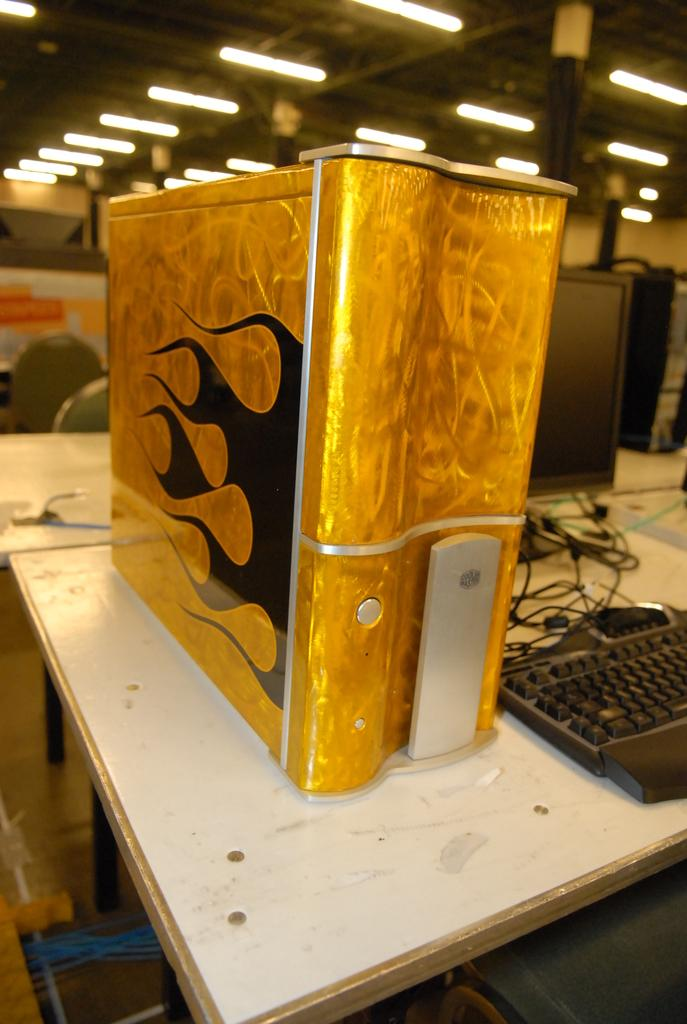What piece of furniture is present in the image? There is a table in the image. What object with a metallic appearance is on the table? There is a gold-colored object on the table. What electronic device is on the table? There is a keyboard and a monitor on the table. What type of monitor is likely being used? The monitor is likely a CPU. What can be seen attached to the rooftop in the image? There are lights attached to the rooftop. What nation is represented by the flag on the van in the image? There is no van or flag present in the image. How does love manifest itself in the image? Love is not a tangible object or action that can be observed in the image. 